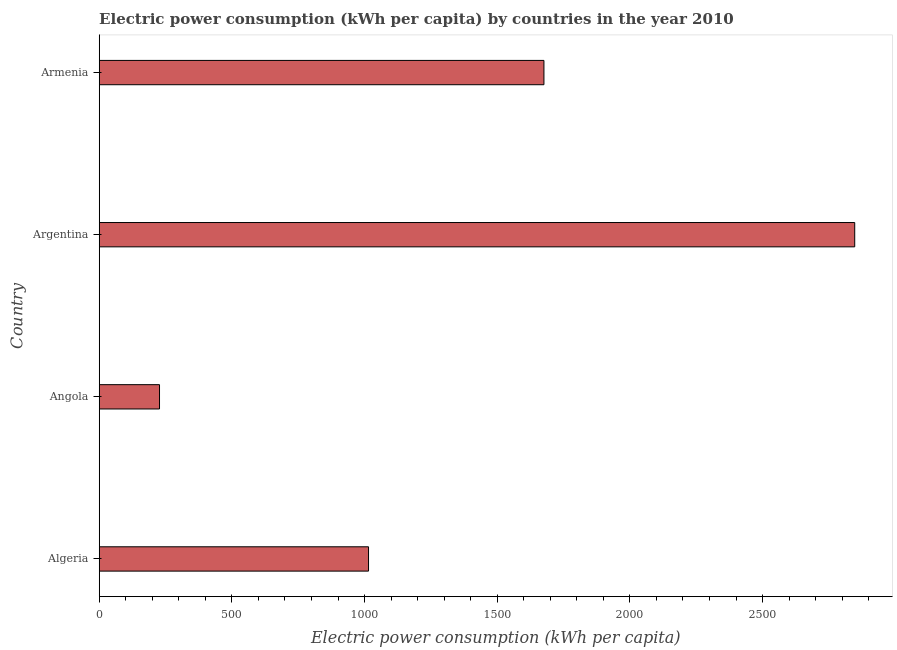Does the graph contain grids?
Offer a terse response. No. What is the title of the graph?
Provide a short and direct response. Electric power consumption (kWh per capita) by countries in the year 2010. What is the label or title of the X-axis?
Offer a terse response. Electric power consumption (kWh per capita). What is the electric power consumption in Argentina?
Your response must be concise. 2847.33. Across all countries, what is the maximum electric power consumption?
Your answer should be compact. 2847.33. Across all countries, what is the minimum electric power consumption?
Keep it short and to the point. 227.24. In which country was the electric power consumption minimum?
Offer a very short reply. Angola. What is the sum of the electric power consumption?
Your answer should be very brief. 5765.61. What is the difference between the electric power consumption in Algeria and Argentina?
Your response must be concise. -1832.35. What is the average electric power consumption per country?
Provide a short and direct response. 1441.4. What is the median electric power consumption?
Offer a very short reply. 1345.52. In how many countries, is the electric power consumption greater than 2500 kWh per capita?
Your response must be concise. 1. What is the ratio of the electric power consumption in Angola to that in Argentina?
Your answer should be compact. 0.08. Is the electric power consumption in Algeria less than that in Armenia?
Provide a succinct answer. Yes. Is the difference between the electric power consumption in Algeria and Armenia greater than the difference between any two countries?
Keep it short and to the point. No. What is the difference between the highest and the second highest electric power consumption?
Offer a very short reply. 1171.27. What is the difference between the highest and the lowest electric power consumption?
Give a very brief answer. 2620.09. How many bars are there?
Your answer should be very brief. 4. Are all the bars in the graph horizontal?
Give a very brief answer. Yes. How many countries are there in the graph?
Offer a very short reply. 4. What is the difference between two consecutive major ticks on the X-axis?
Keep it short and to the point. 500. Are the values on the major ticks of X-axis written in scientific E-notation?
Offer a very short reply. No. What is the Electric power consumption (kWh per capita) in Algeria?
Keep it short and to the point. 1014.98. What is the Electric power consumption (kWh per capita) of Angola?
Provide a succinct answer. 227.24. What is the Electric power consumption (kWh per capita) in Argentina?
Make the answer very short. 2847.33. What is the Electric power consumption (kWh per capita) of Armenia?
Offer a very short reply. 1676.06. What is the difference between the Electric power consumption (kWh per capita) in Algeria and Angola?
Your answer should be very brief. 787.74. What is the difference between the Electric power consumption (kWh per capita) in Algeria and Argentina?
Your answer should be compact. -1832.35. What is the difference between the Electric power consumption (kWh per capita) in Algeria and Armenia?
Offer a terse response. -661.08. What is the difference between the Electric power consumption (kWh per capita) in Angola and Argentina?
Provide a succinct answer. -2620.09. What is the difference between the Electric power consumption (kWh per capita) in Angola and Armenia?
Your answer should be compact. -1448.82. What is the difference between the Electric power consumption (kWh per capita) in Argentina and Armenia?
Keep it short and to the point. 1171.27. What is the ratio of the Electric power consumption (kWh per capita) in Algeria to that in Angola?
Your answer should be very brief. 4.47. What is the ratio of the Electric power consumption (kWh per capita) in Algeria to that in Argentina?
Your answer should be very brief. 0.36. What is the ratio of the Electric power consumption (kWh per capita) in Algeria to that in Armenia?
Keep it short and to the point. 0.61. What is the ratio of the Electric power consumption (kWh per capita) in Angola to that in Argentina?
Make the answer very short. 0.08. What is the ratio of the Electric power consumption (kWh per capita) in Angola to that in Armenia?
Your answer should be compact. 0.14. What is the ratio of the Electric power consumption (kWh per capita) in Argentina to that in Armenia?
Offer a very short reply. 1.7. 